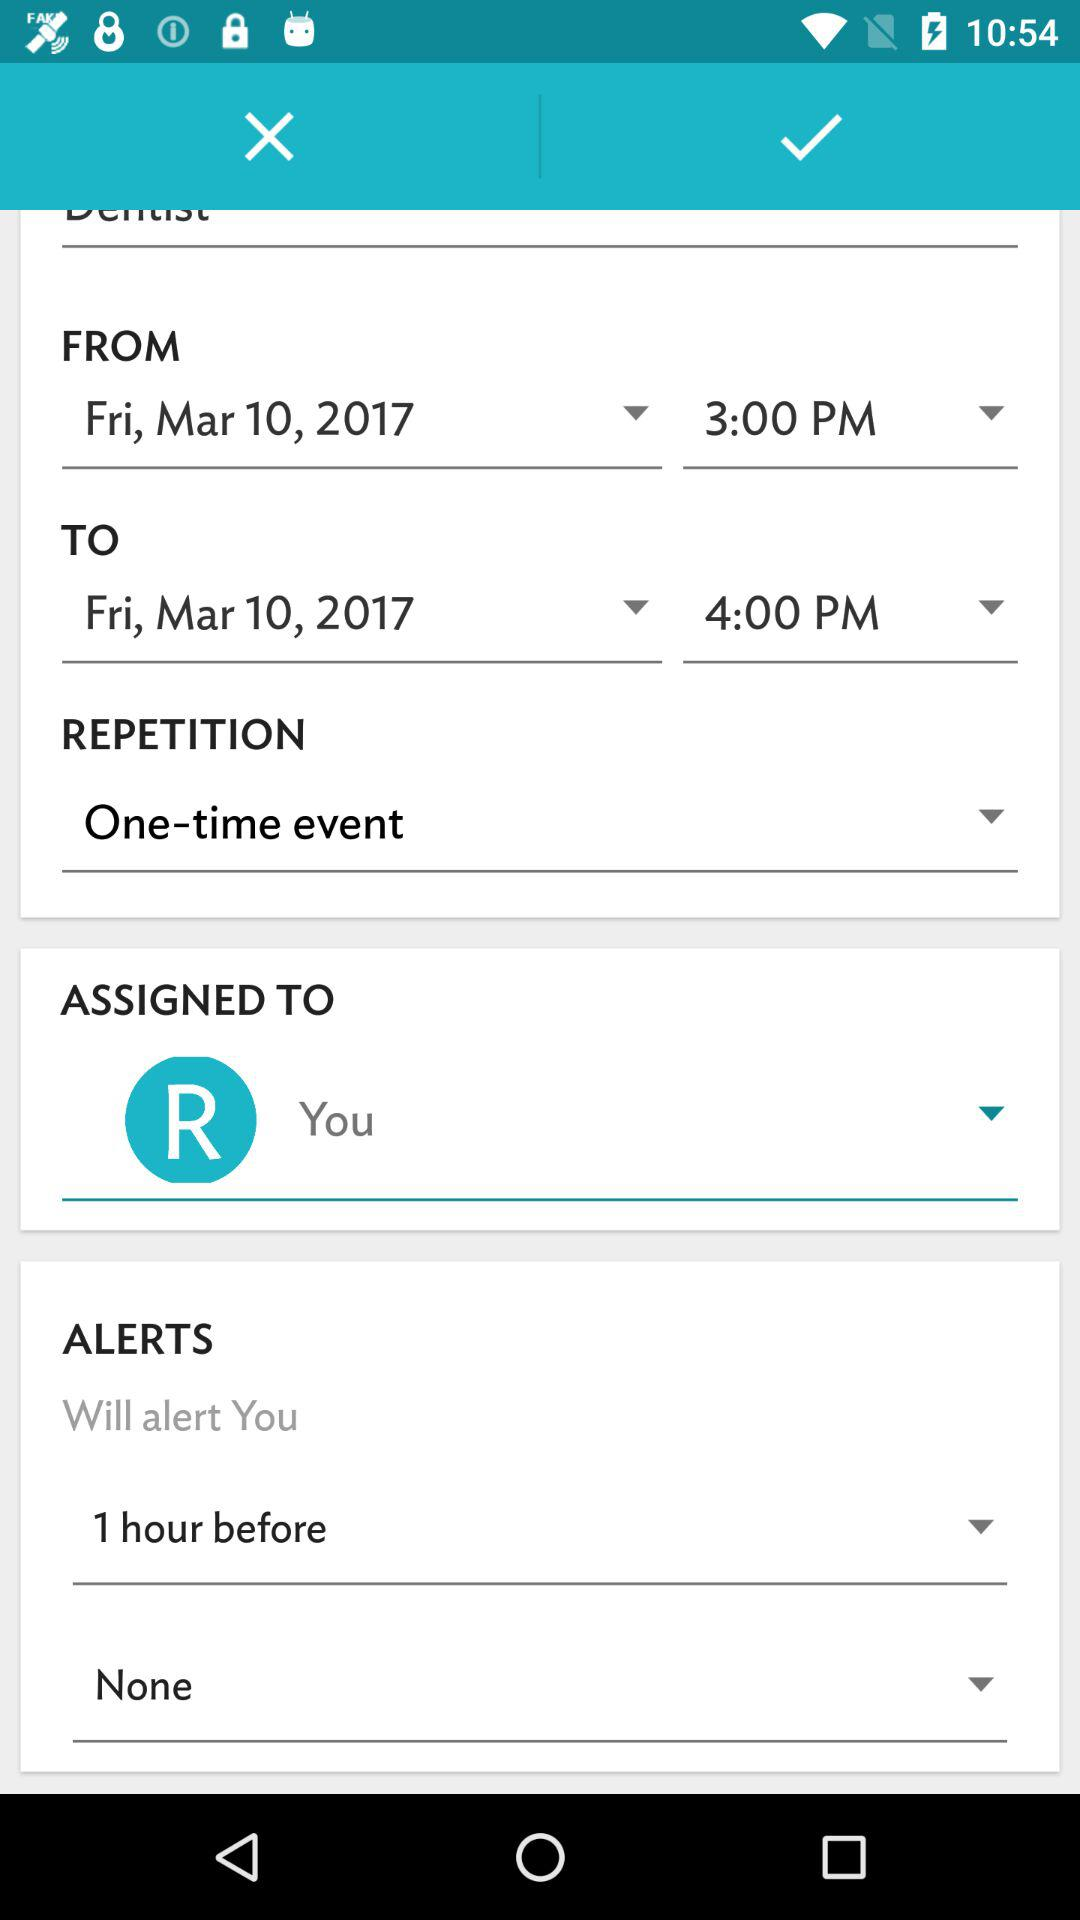Who is this event assigned to?
Answer the question using a single word or phrase. You 